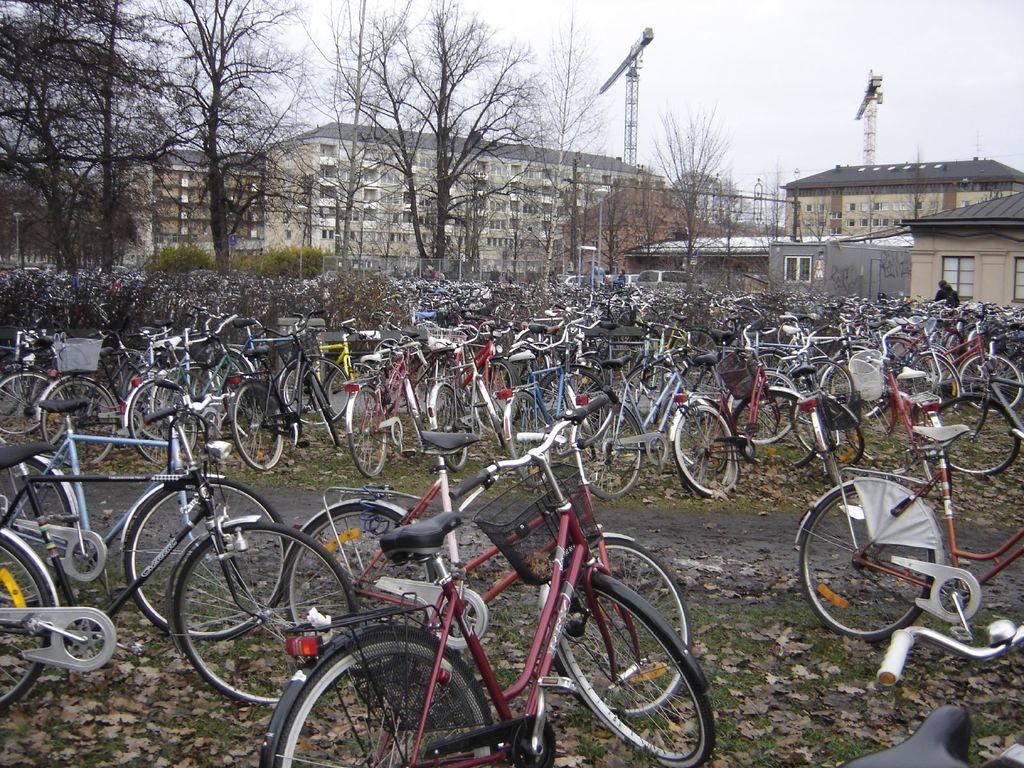How would you summarize this image in a sentence or two? In this image, we can see some bicycles and there are some dried leaves on the ground, in the background there are some trees and there are some buildings, at the top there is a sky which is cloudy. 